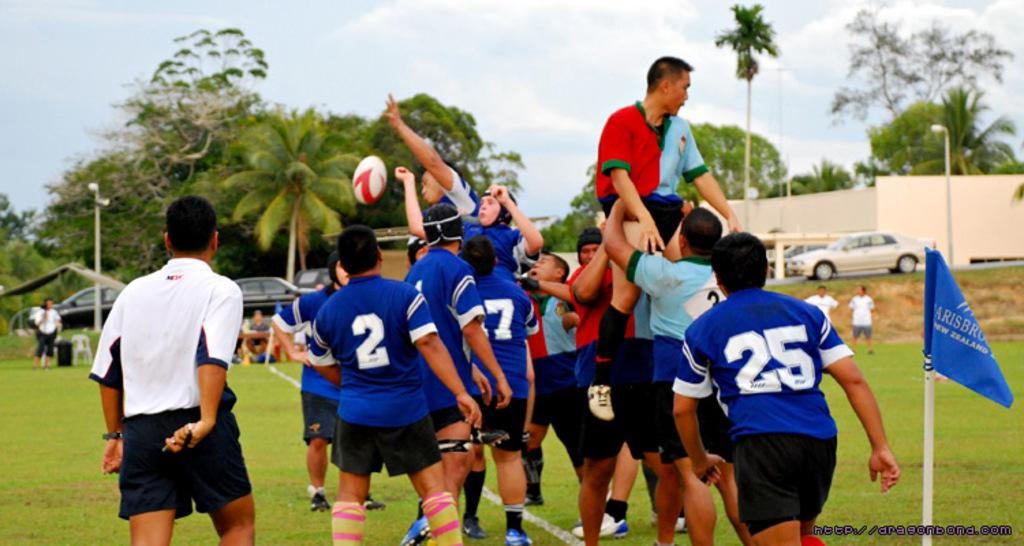How many people are in the group visible in the image? There is a group of people in the image, but the exact number cannot be determined from the provided facts. What is the flag associated with in the image? The presence of a flag suggests a possible event or gathering, but the specific context is not clear from the facts. What is happening with the ball in the image? The ball is in the air in the image, which could indicate a game or activity involving the ball. What types of vehicles can be seen in the background of the image? The fact that there are vehicles in the background of the image suggests that the scene may be taking place near a road or parking area, but the specific types of vehicles are not mentioned. What are the poles used for in the background of the image? The presence of poles in the background of the image could indicate a sports field or other outdoor area, but their specific purpose is not clear from the facts. What is the wall made of in the background of the image? The fact that there is a wall in the background of the image suggests a possible boundary or enclosure, but the material it is made of is not mentioned. What types of trees are visible in the background of the image? The fact that there are trees in the background of the image suggests a natural or outdoor setting, but the specific types of trees are not mentioned. What is visible in the sky in the background of the image? The sky is visible in the background of the image, but the specific weather or atmospheric conditions are not mentioned. Where is the kitten sitting on the shelf in the image? There is no kitten or shelf present in the image. What type of steel is used to construct the vehicles in the background of the image? There is no information about the materials used to construct the vehicles in the image. 